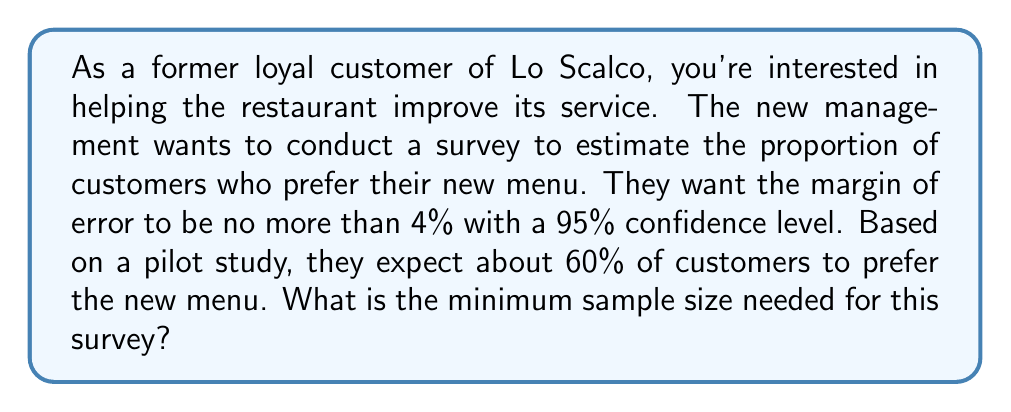What is the answer to this math problem? To determine the minimum sample size needed, we'll use the formula for sample size calculation for estimating a proportion:

$$n = \frac{z^2 \cdot p(1-p)}{E^2}$$

Where:
$n$ = required sample size
$z$ = z-score for the desired confidence level
$p$ = expected proportion
$E$ = desired margin of error

Step 1: Identify the known values
- Confidence level = 95% → $z = 1.96$
- Expected proportion, $p = 0.60$
- Margin of error, $E = 0.04$

Step 2: Plug the values into the formula
$$n = \frac{1.96^2 \cdot 0.60(1-0.60)}{0.04^2}$$

Step 3: Calculate
$$n = \frac{3.8416 \cdot 0.60 \cdot 0.40}{0.0016}$$
$$n = \frac{0.921984}{0.0016}$$
$$n = 576.24$$

Step 4: Round up to the nearest whole number
Since we can't survey a fraction of a person, we round up to 577.

Therefore, the minimum sample size needed is 577 customers.
Answer: 577 customers 